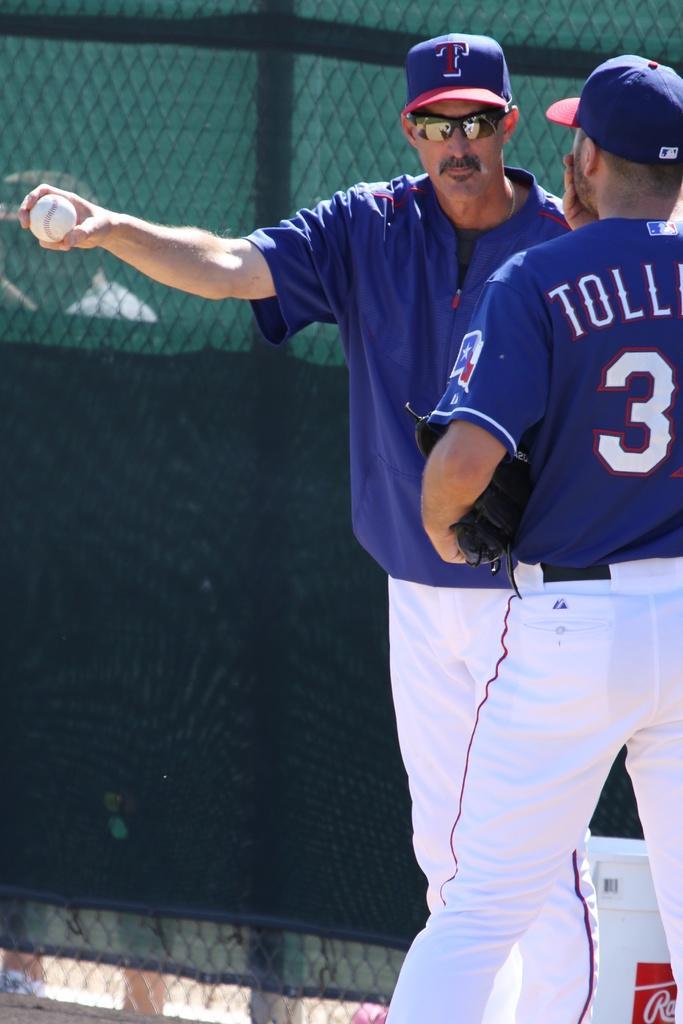In one or two sentences, can you explain what this image depicts? This image consists of two persons. They are wearing the same dress. They are wearing caps. One of them is holding the ball in his hand. There is a net behind them. 